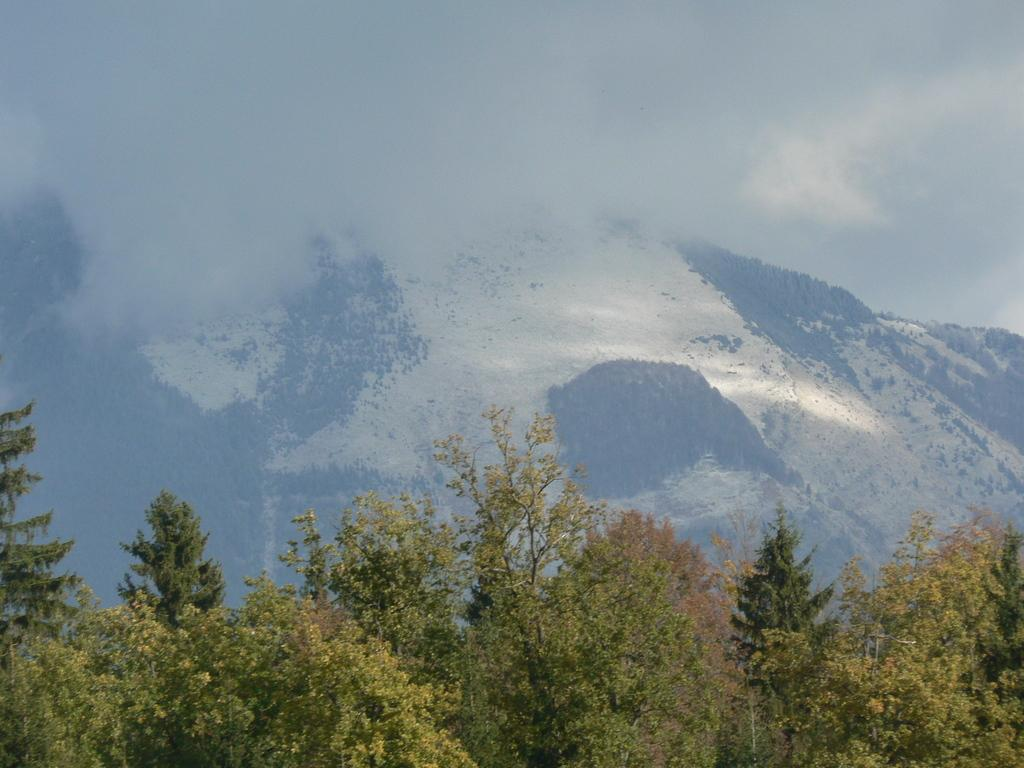What type of natural features can be seen in the image? There are trees and mountains in the image. What atmospheric condition is present in the image? There is fog in the image. Why is the room in the image so cold? There is no room present in the image; it is an outdoor scene with trees, mountains, and fog. 